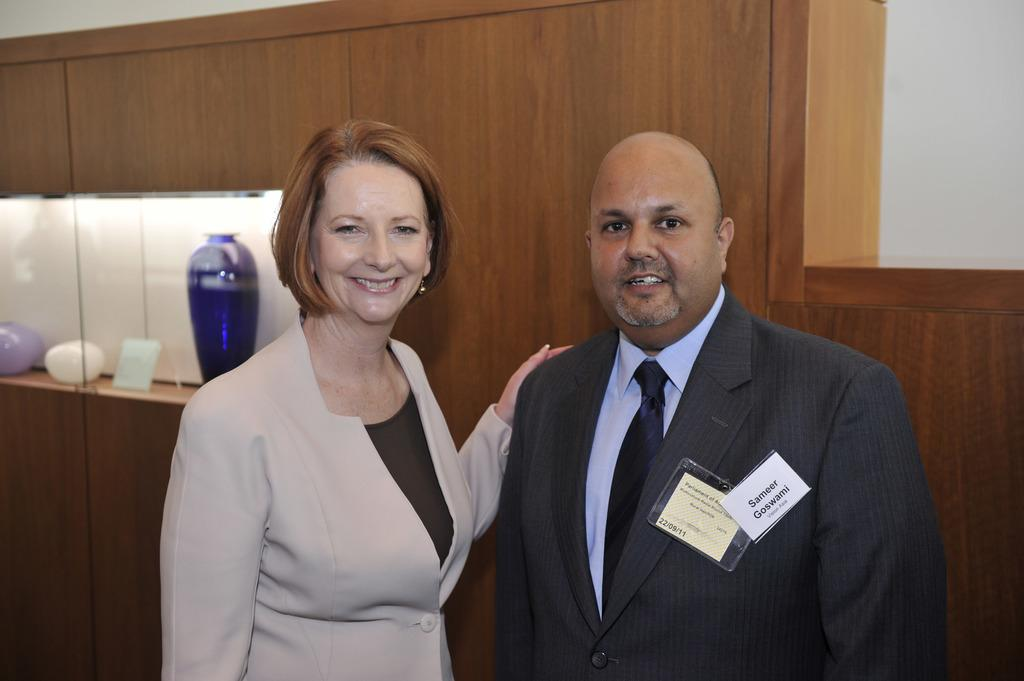Who is present in the image? There is a man and a woman in the image. What are the man and woman doing in the image? Both the man and the woman are standing and smiling. What objects can be seen on a shelf in the image? There are vases and a frame on a shelf in the image. What type of background is visible in the image? There is a wooden object and a wall in the background of the image. Can you see a boat in the image? No, there is no boat present in the image. Are the man and woman kissing in the image? No, the man and woman are standing and smiling, but they are not kissing in the image. 